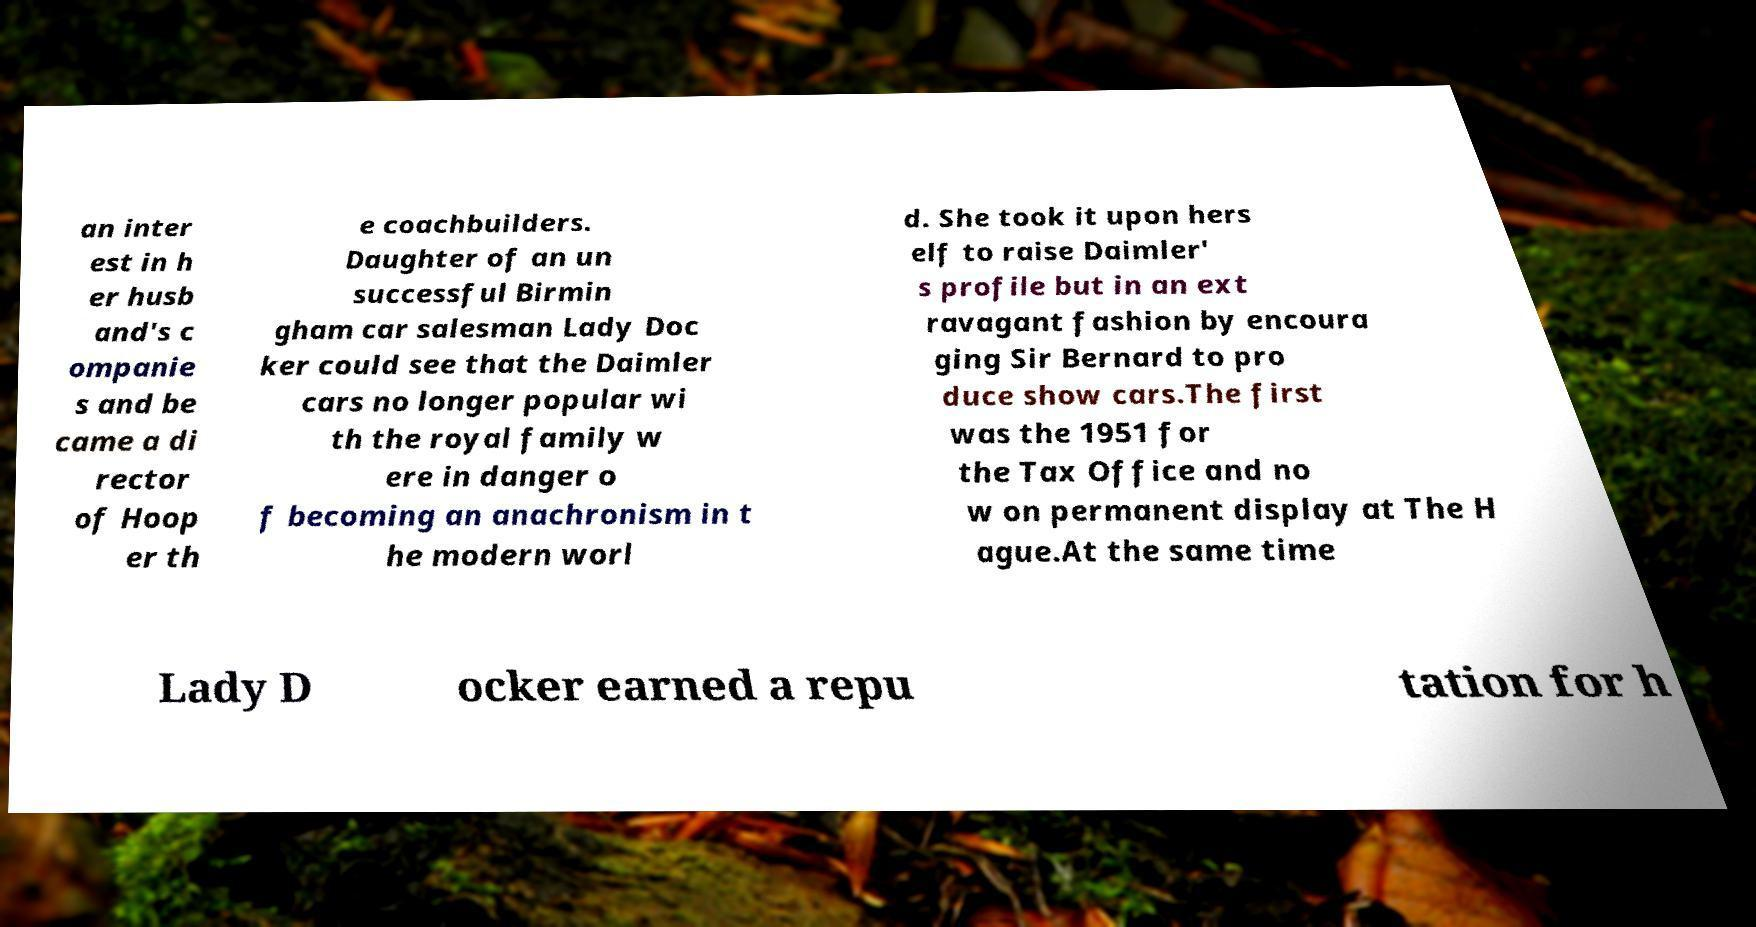Can you accurately transcribe the text from the provided image for me? an inter est in h er husb and's c ompanie s and be came a di rector of Hoop er th e coachbuilders. Daughter of an un successful Birmin gham car salesman Lady Doc ker could see that the Daimler cars no longer popular wi th the royal family w ere in danger o f becoming an anachronism in t he modern worl d. She took it upon hers elf to raise Daimler' s profile but in an ext ravagant fashion by encoura ging Sir Bernard to pro duce show cars.The first was the 1951 for the Tax Office and no w on permanent display at The H ague.At the same time Lady D ocker earned a repu tation for h 